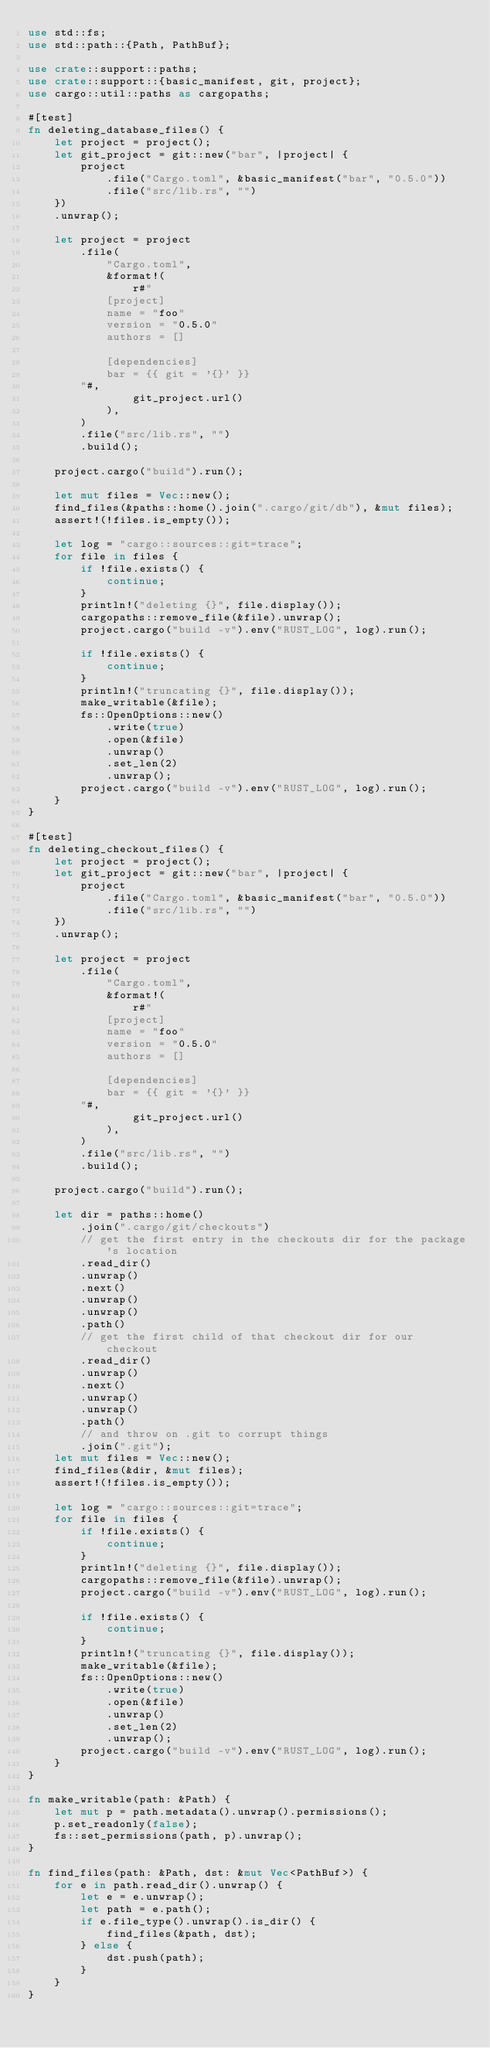<code> <loc_0><loc_0><loc_500><loc_500><_Rust_>use std::fs;
use std::path::{Path, PathBuf};

use crate::support::paths;
use crate::support::{basic_manifest, git, project};
use cargo::util::paths as cargopaths;

#[test]
fn deleting_database_files() {
    let project = project();
    let git_project = git::new("bar", |project| {
        project
            .file("Cargo.toml", &basic_manifest("bar", "0.5.0"))
            .file("src/lib.rs", "")
    })
    .unwrap();

    let project = project
        .file(
            "Cargo.toml",
            &format!(
                r#"
            [project]
            name = "foo"
            version = "0.5.0"
            authors = []

            [dependencies]
            bar = {{ git = '{}' }}
        "#,
                git_project.url()
            ),
        )
        .file("src/lib.rs", "")
        .build();

    project.cargo("build").run();

    let mut files = Vec::new();
    find_files(&paths::home().join(".cargo/git/db"), &mut files);
    assert!(!files.is_empty());

    let log = "cargo::sources::git=trace";
    for file in files {
        if !file.exists() {
            continue;
        }
        println!("deleting {}", file.display());
        cargopaths::remove_file(&file).unwrap();
        project.cargo("build -v").env("RUST_LOG", log).run();

        if !file.exists() {
            continue;
        }
        println!("truncating {}", file.display());
        make_writable(&file);
        fs::OpenOptions::new()
            .write(true)
            .open(&file)
            .unwrap()
            .set_len(2)
            .unwrap();
        project.cargo("build -v").env("RUST_LOG", log).run();
    }
}

#[test]
fn deleting_checkout_files() {
    let project = project();
    let git_project = git::new("bar", |project| {
        project
            .file("Cargo.toml", &basic_manifest("bar", "0.5.0"))
            .file("src/lib.rs", "")
    })
    .unwrap();

    let project = project
        .file(
            "Cargo.toml",
            &format!(
                r#"
            [project]
            name = "foo"
            version = "0.5.0"
            authors = []

            [dependencies]
            bar = {{ git = '{}' }}
        "#,
                git_project.url()
            ),
        )
        .file("src/lib.rs", "")
        .build();

    project.cargo("build").run();

    let dir = paths::home()
        .join(".cargo/git/checkouts")
        // get the first entry in the checkouts dir for the package's location
        .read_dir()
        .unwrap()
        .next()
        .unwrap()
        .unwrap()
        .path()
        // get the first child of that checkout dir for our checkout
        .read_dir()
        .unwrap()
        .next()
        .unwrap()
        .unwrap()
        .path()
        // and throw on .git to corrupt things
        .join(".git");
    let mut files = Vec::new();
    find_files(&dir, &mut files);
    assert!(!files.is_empty());

    let log = "cargo::sources::git=trace";
    for file in files {
        if !file.exists() {
            continue;
        }
        println!("deleting {}", file.display());
        cargopaths::remove_file(&file).unwrap();
        project.cargo("build -v").env("RUST_LOG", log).run();

        if !file.exists() {
            continue;
        }
        println!("truncating {}", file.display());
        make_writable(&file);
        fs::OpenOptions::new()
            .write(true)
            .open(&file)
            .unwrap()
            .set_len(2)
            .unwrap();
        project.cargo("build -v").env("RUST_LOG", log).run();
    }
}

fn make_writable(path: &Path) {
    let mut p = path.metadata().unwrap().permissions();
    p.set_readonly(false);
    fs::set_permissions(path, p).unwrap();
}

fn find_files(path: &Path, dst: &mut Vec<PathBuf>) {
    for e in path.read_dir().unwrap() {
        let e = e.unwrap();
        let path = e.path();
        if e.file_type().unwrap().is_dir() {
            find_files(&path, dst);
        } else {
            dst.push(path);
        }
    }
}
</code> 